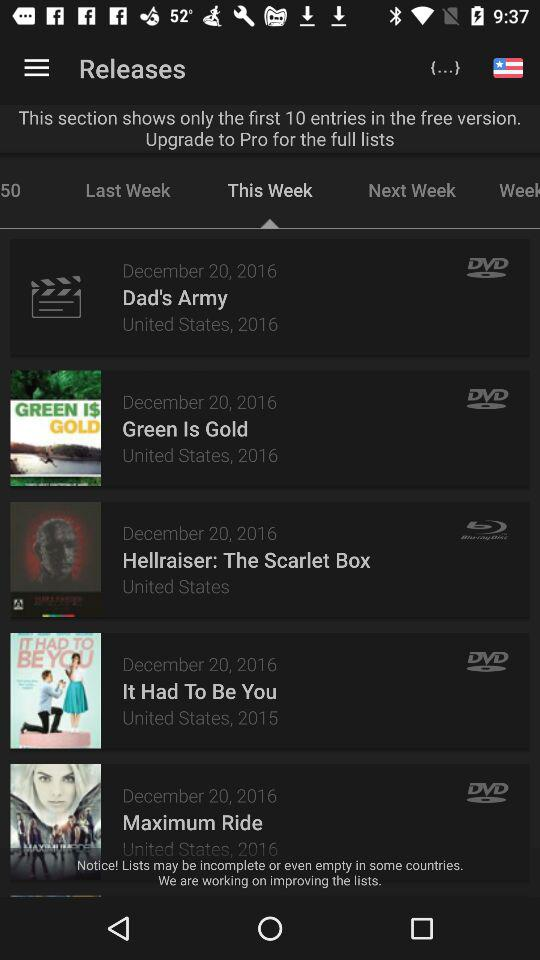In what year was the movie "It Had To Be You" released in the United States? It was released in 2015. 